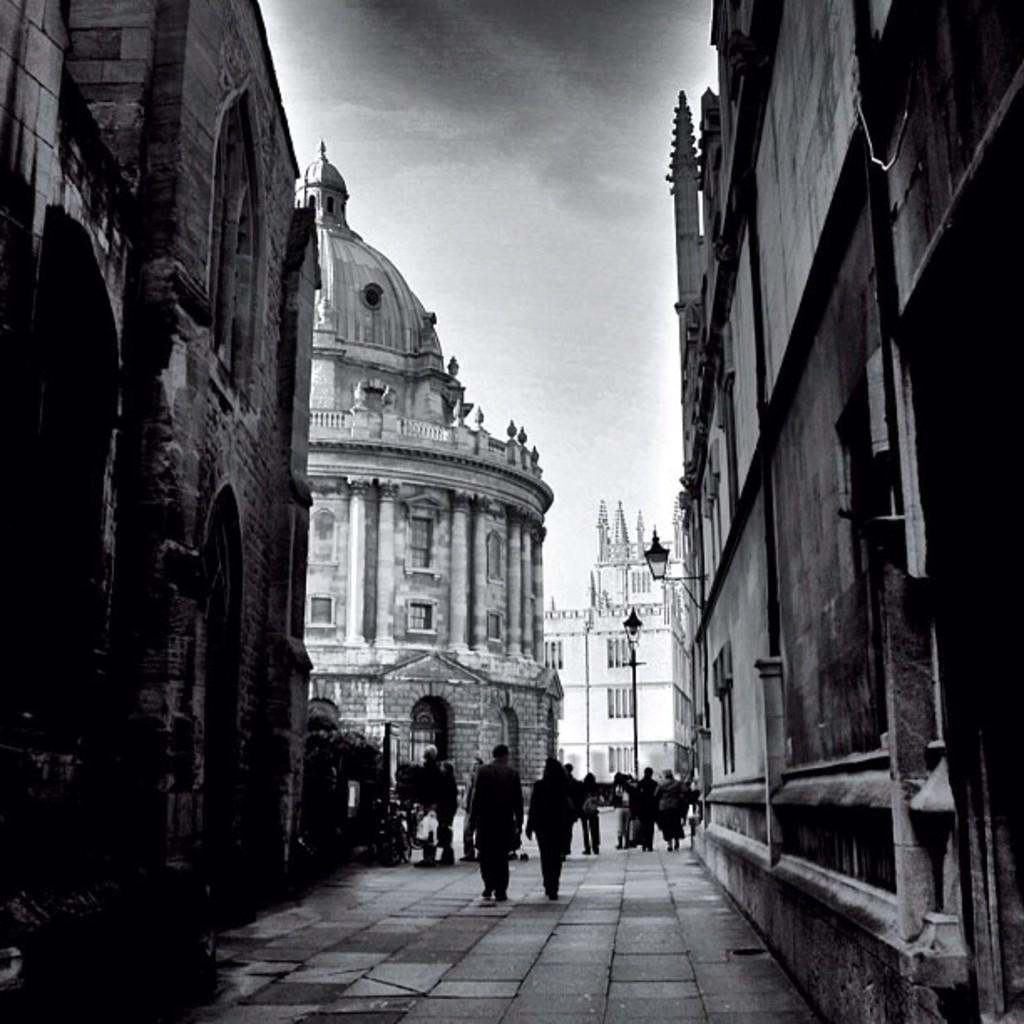What is the color scheme of the image? The image is black and white. Who or what can be seen in the image? There are people and buildings in the image. What is the purpose of the light pole in the image? The light pole provides illumination in the image. What can be seen in the background of the image? There is sky visible in the image. Where is the lamp located in the image? A lamp is attached to a wall in the image. What flavor of rock can be seen in the image? There is no rock present in the image, and therefore no flavor can be determined. 